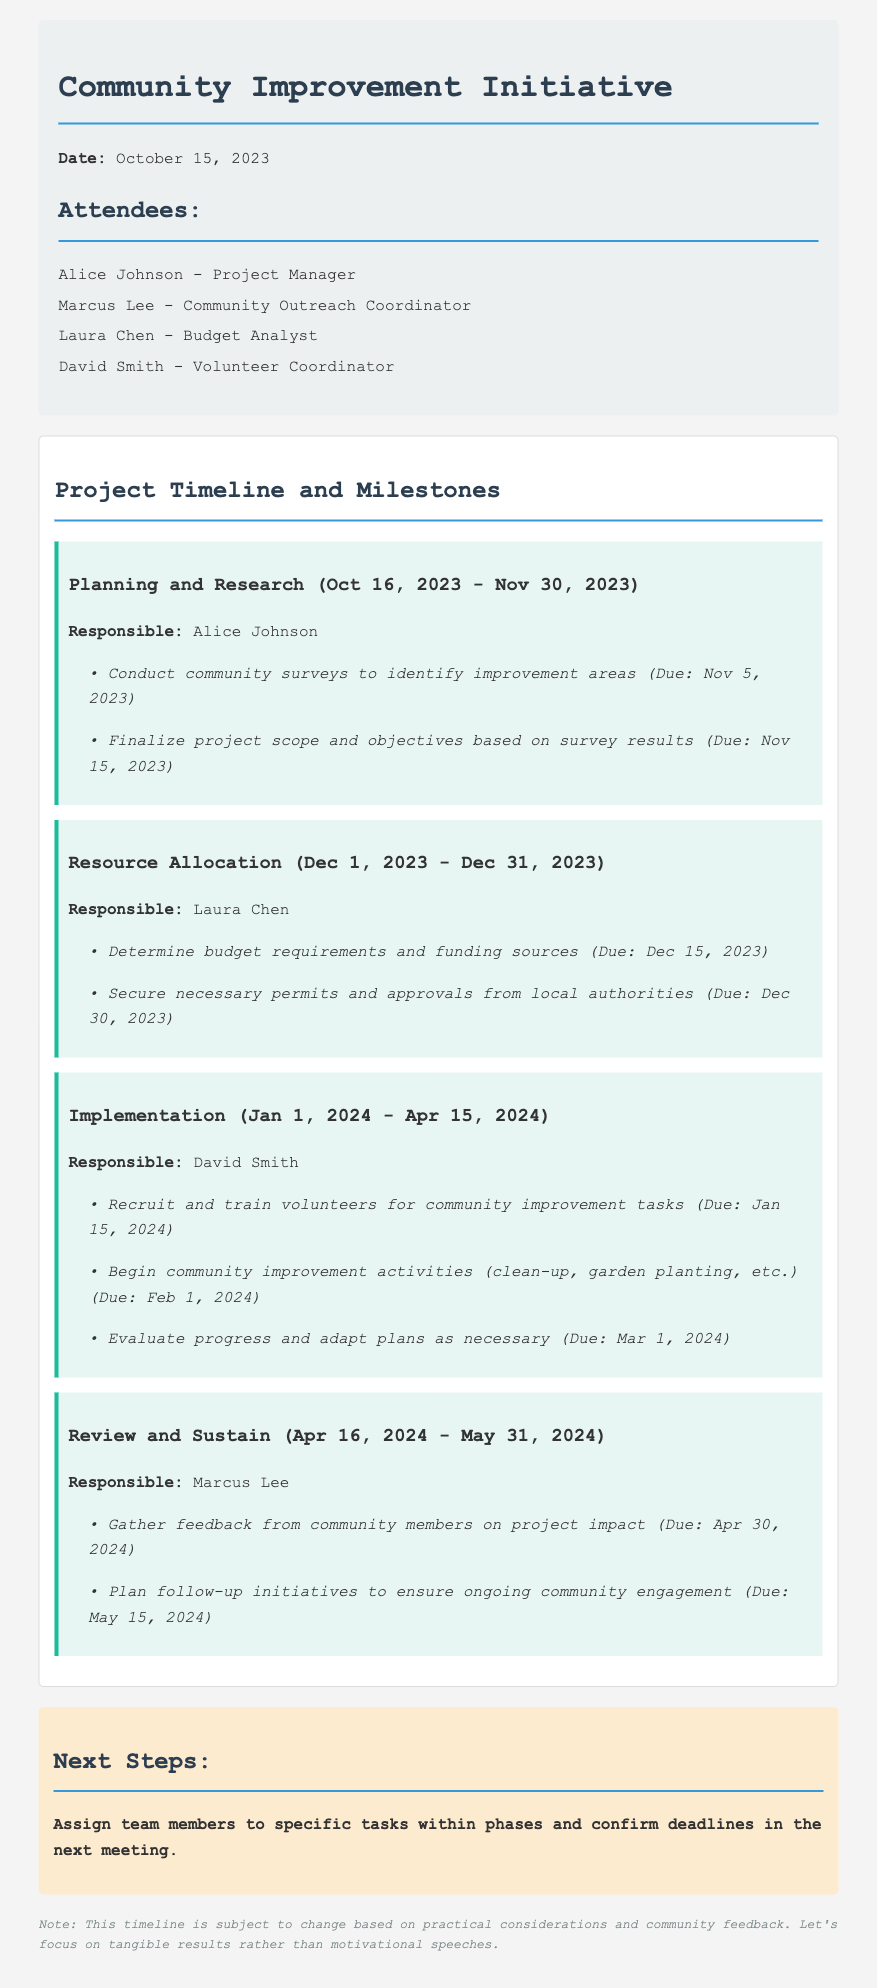What is the project end date? The project end date is marked as May 31, 2024 in the document under the Review and Sustain phase.
Answer: May 31, 2024 Who is responsible for the Planning and Research phase? The Planning and Research phase is assigned to Alice Johnson, as stated in the document.
Answer: Alice Johnson What is the deadline for securing permits? The deadline for securing necessary permits is listed in the Resource Allocation phase.
Answer: December 30, 2023 How long will the Implementation phase last? The Implementation phase starts on January 1, 2024, and ends on April 15, 2024, resulting in a duration of approximately 3.5 months.
Answer: 3.5 months What is the first milestone in the Review and Sustain phase? The first milestone mentioned in the Review and Sustain phase is to gather feedback, which has a specific due date.
Answer: April 30, 2024 Which team member is in charge of evaluating progress? The document specifies that David Smith is responsible for evaluating progress during the implementation phase.
Answer: David Smith How many phases are included in the project timeline? The project timeline outlines a total of four distinct phases, each covering different project activities.
Answer: Four What is the next step mentioned for the team? The next step stated in the document is to assign team members to specific tasks and confirm deadlines.
Answer: Assign team members What type of feedback is anticipated from the community? The document indicates that feedback to be gathered will focus on the project impact on the community.
Answer: Project impact 